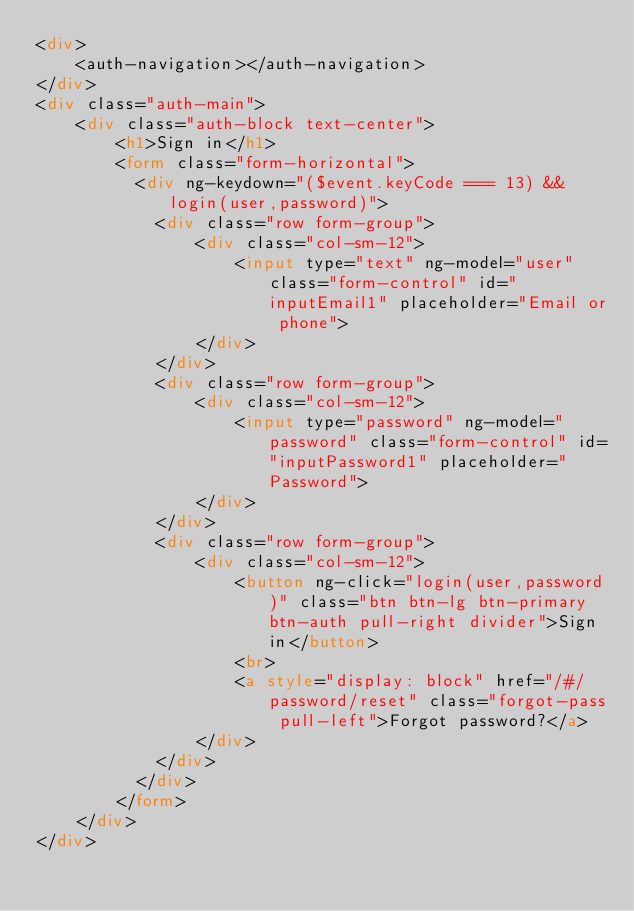<code> <loc_0><loc_0><loc_500><loc_500><_HTML_><div>
    <auth-navigation></auth-navigation>
</div>
<div class="auth-main">
    <div class="auth-block text-center">
        <h1>Sign in</h1>
        <form class="form-horizontal">
          <div ng-keydown="($event.keyCode === 13) && login(user,password)">
            <div class="row form-group">
                <div class="col-sm-12">
                    <input type="text" ng-model="user" class="form-control" id="inputEmail1" placeholder="Email or phone">
                </div>
            </div>
            <div class="row form-group">
                <div class="col-sm-12">
                    <input type="password" ng-model="password" class="form-control" id="inputPassword1" placeholder="Password">
                </div>
            </div>
            <div class="row form-group">
                <div class="col-sm-12">
                    <button ng-click="login(user,password)" class="btn btn-lg btn-primary btn-auth pull-right divider">Sign in</button>
                    <br>
                    <a style="display: block" href="/#/password/reset" class="forgot-pass pull-left">Forgot password?</a>
                </div>
            </div>
          </div>
        </form>
    </div>
</div>
</code> 